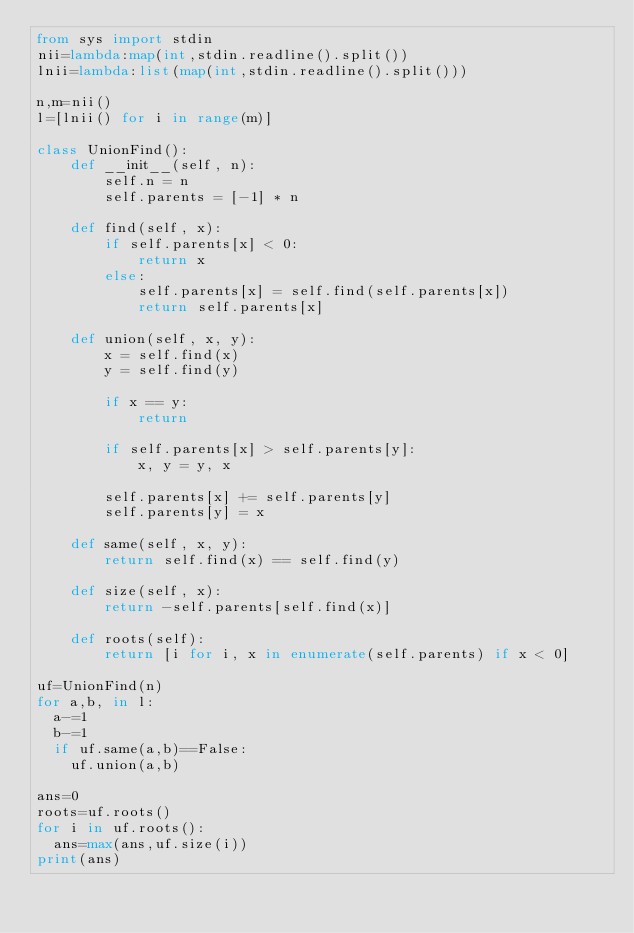Convert code to text. <code><loc_0><loc_0><loc_500><loc_500><_Python_>from sys import stdin
nii=lambda:map(int,stdin.readline().split())
lnii=lambda:list(map(int,stdin.readline().split()))

n,m=nii()
l=[lnii() for i in range(m)]

class UnionFind():
    def __init__(self, n):
        self.n = n
        self.parents = [-1] * n

    def find(self, x):
        if self.parents[x] < 0:
            return x
        else:
            self.parents[x] = self.find(self.parents[x])
            return self.parents[x]

    def union(self, x, y):
        x = self.find(x)
        y = self.find(y)

        if x == y:
            return

        if self.parents[x] > self.parents[y]:
            x, y = y, x

        self.parents[x] += self.parents[y]
        self.parents[y] = x

    def same(self, x, y):
        return self.find(x) == self.find(y)

    def size(self, x):
        return -self.parents[self.find(x)]

    def roots(self):
        return [i for i, x in enumerate(self.parents) if x < 0]

uf=UnionFind(n)
for a,b, in l:
  a-=1
  b-=1
  if uf.same(a,b)==False:
    uf.union(a,b)

ans=0
roots=uf.roots()
for i in uf.roots():
  ans=max(ans,uf.size(i))
print(ans)</code> 